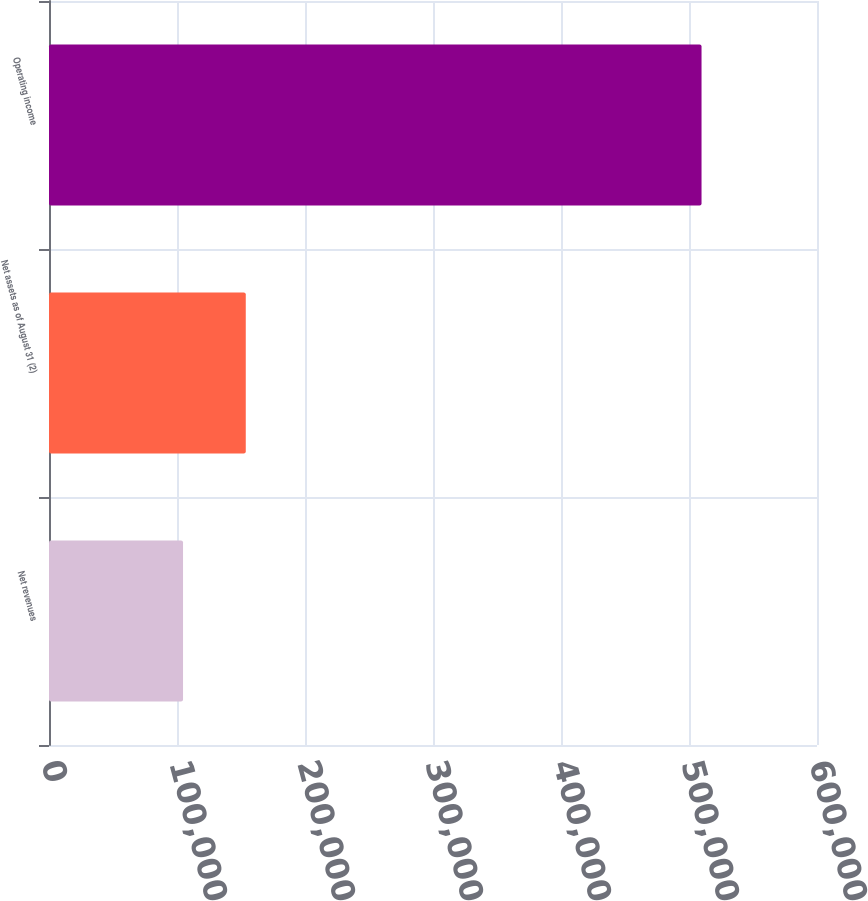<chart> <loc_0><loc_0><loc_500><loc_500><bar_chart><fcel>Net revenues<fcel>Net assets as of August 31 (2)<fcel>Operating income<nl><fcel>104709<fcel>153725<fcel>509793<nl></chart> 